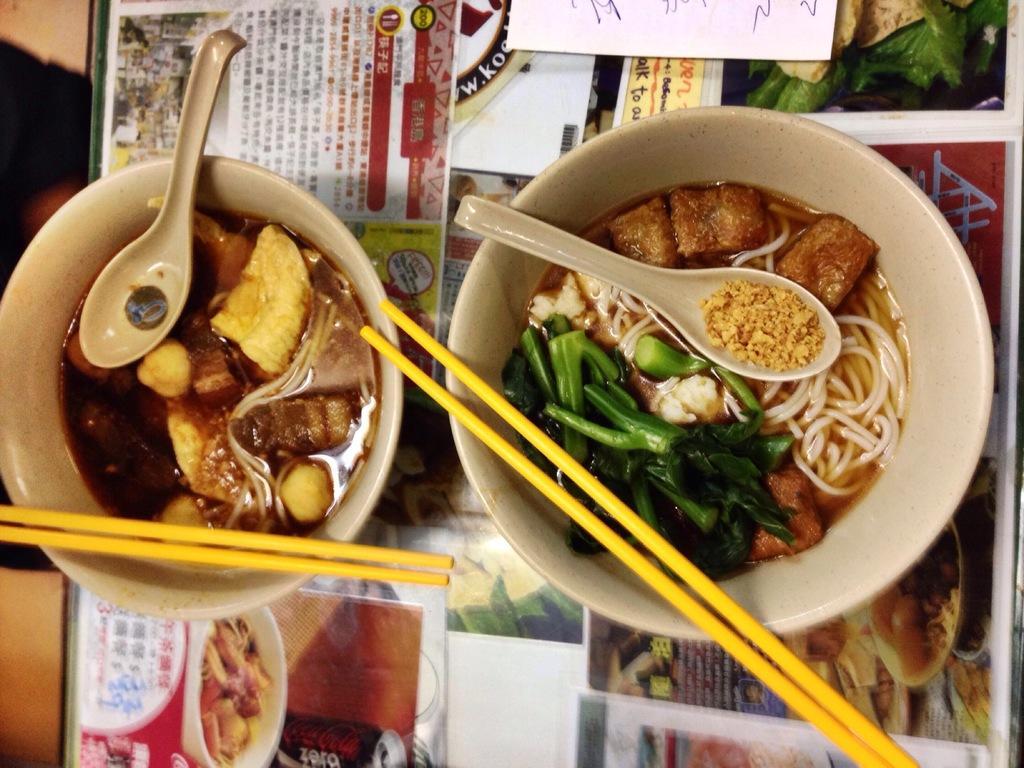In one or two sentences, can you explain what this image depicts? In this picture we can see two bowls and chop sticks on it and spoons in it and this two bowls are placed on a floor glass papers on it. 